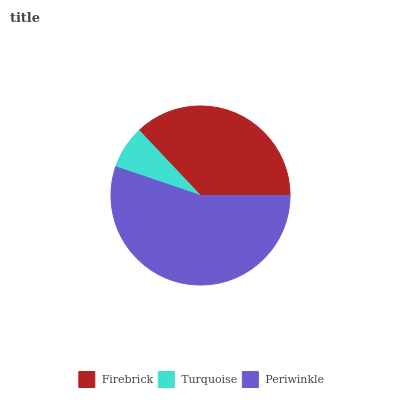Is Turquoise the minimum?
Answer yes or no. Yes. Is Periwinkle the maximum?
Answer yes or no. Yes. Is Periwinkle the minimum?
Answer yes or no. No. Is Turquoise the maximum?
Answer yes or no. No. Is Periwinkle greater than Turquoise?
Answer yes or no. Yes. Is Turquoise less than Periwinkle?
Answer yes or no. Yes. Is Turquoise greater than Periwinkle?
Answer yes or no. No. Is Periwinkle less than Turquoise?
Answer yes or no. No. Is Firebrick the high median?
Answer yes or no. Yes. Is Firebrick the low median?
Answer yes or no. Yes. Is Periwinkle the high median?
Answer yes or no. No. Is Periwinkle the low median?
Answer yes or no. No. 